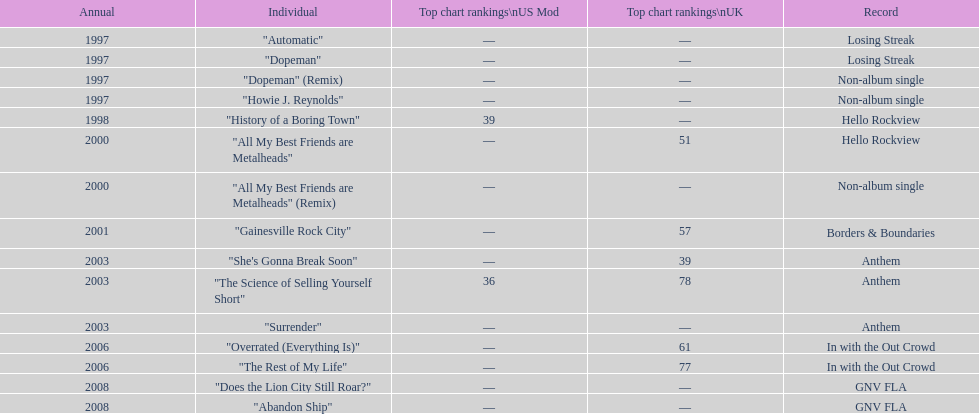Compare the chart positions between the us and the uk for the science of selling yourself short, where did it do better? US. 